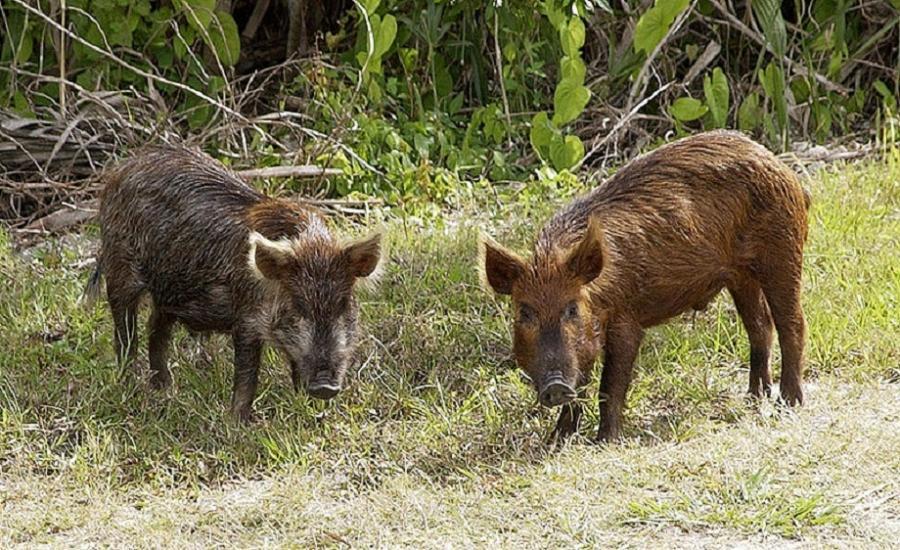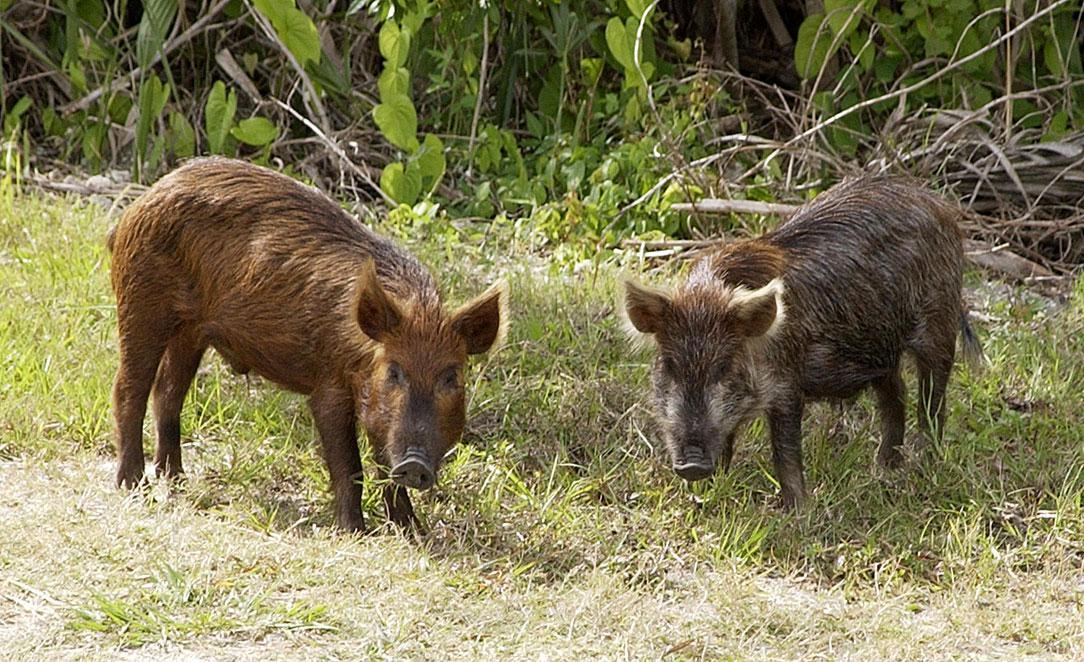The first image is the image on the left, the second image is the image on the right. Examine the images to the left and right. Is the description "In one of the image there are baby pigs near a mother pig" accurate? Answer yes or no. No. The first image is the image on the left, the second image is the image on the right. Assess this claim about the two images: "There is at least two boars in the left image.". Correct or not? Answer yes or no. Yes. 